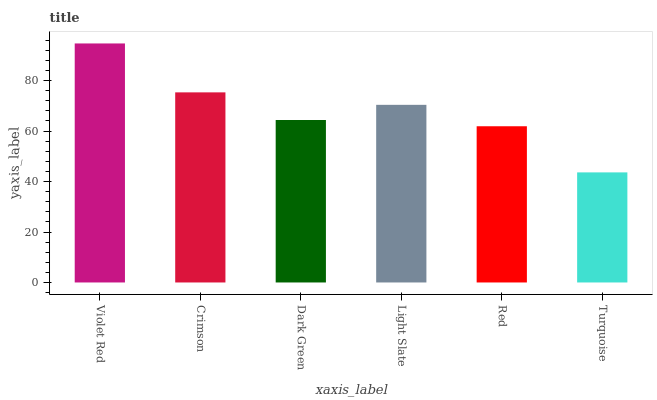Is Crimson the minimum?
Answer yes or no. No. Is Crimson the maximum?
Answer yes or no. No. Is Violet Red greater than Crimson?
Answer yes or no. Yes. Is Crimson less than Violet Red?
Answer yes or no. Yes. Is Crimson greater than Violet Red?
Answer yes or no. No. Is Violet Red less than Crimson?
Answer yes or no. No. Is Light Slate the high median?
Answer yes or no. Yes. Is Dark Green the low median?
Answer yes or no. Yes. Is Dark Green the high median?
Answer yes or no. No. Is Violet Red the low median?
Answer yes or no. No. 